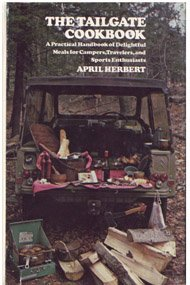What is the genre of this book? The genre of the book is primarily 'Cookbooks, Food & Wine,' specializing in recipes and tips for outdoor dining experiences, particularly tailored for campers and tailgaters. 